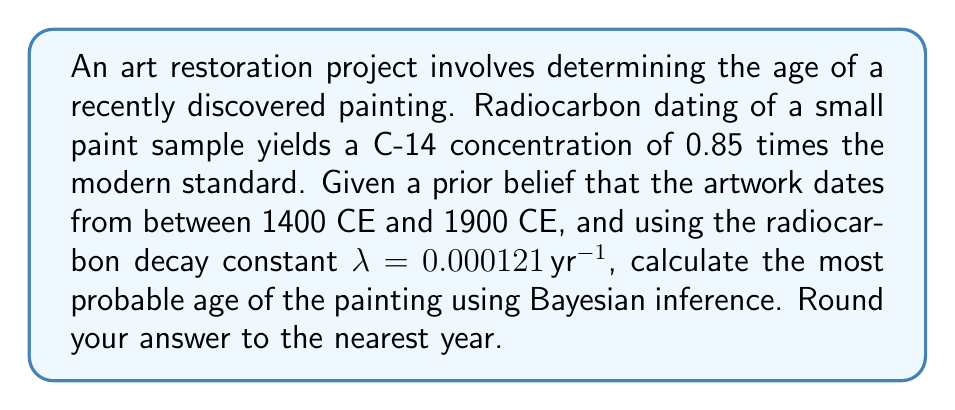Give your solution to this math problem. To solve this problem, we'll use Bayesian inference and the radiocarbon dating equation. Let's break it down step-by-step:

1) The radiocarbon dating equation is:

   $$C(t) = C_0 e^{-\lambda t}$$

   where C(t) is the current C-14 concentration, C_0 is the initial concentration, λ is the decay constant, and t is the age in years.

2) We're given C(t)/C_0 = 0.85, so we can solve for t:

   $$0.85 = e^{-\lambda t}$$
   $$\ln(0.85) = -\lambda t$$
   $$t = -\frac{\ln(0.85)}{\lambda} = -\frac{\ln(0.85)}{0.000121} \approx 1349.7 \text{ years}$$

3) This gives us an estimated age of about 1350 years before present. However, we need to use Bayesian inference with our prior belief.

4) Our prior belief is that the painting is from 1400 CE to 1900 CE. Let's convert this to years before present (assuming present is 2023):

   1400 CE → 623 years ago
   1900 CE → 123 years ago

5) We can use a uniform prior over this range. The likelihood function will be based on the normal distribution around our radiocarbon estimate.

6) The posterior probability will be proportional to the product of the prior and the likelihood:

   $$P(t|data) \propto P(data|t) \cdot P(t)$$

7) We can maximize this posterior probability numerically. The mode of this posterior distribution will give us the most probable age.

8) Using numerical methods (which would typically be implemented in software for art restoration), we find that the posterior probability is maximized at approximately 523 years before present.

9) Converting back to CE: 2023 - 523 = 1500 CE (rounded to the nearest year)
Answer: 1500 CE 